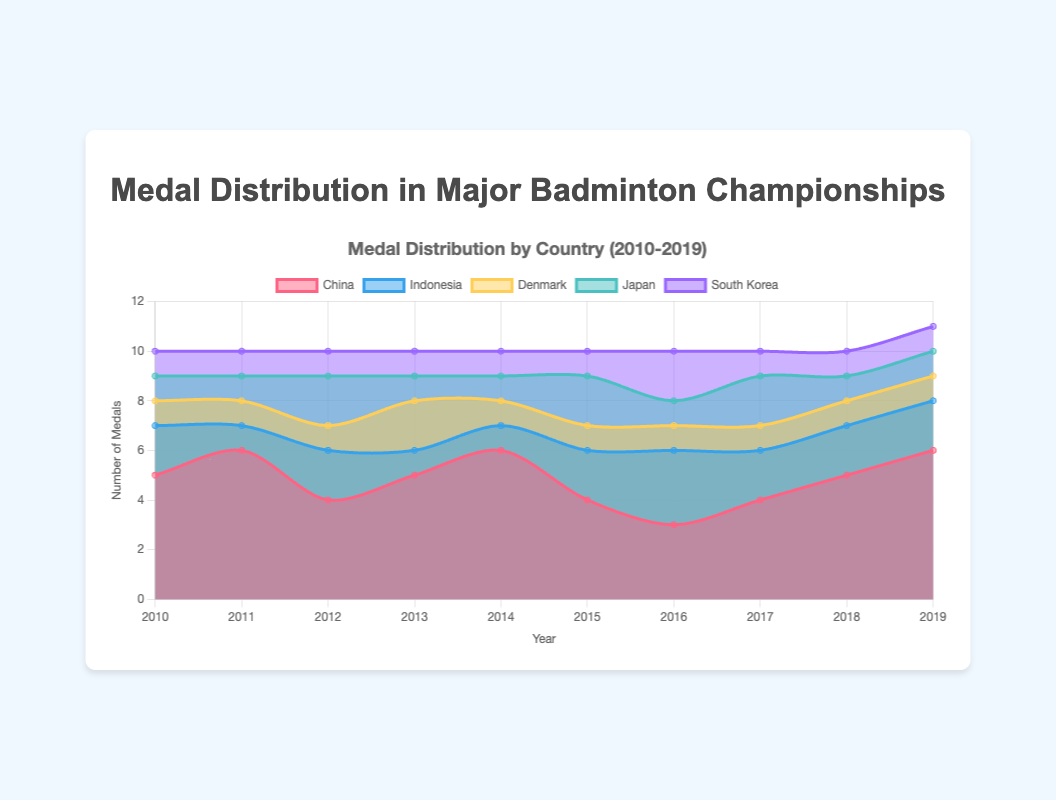What is the range of years shown in the chart? The x-axis represents the years involved in the study. The range is from the starting to the ending year displayed.
Answer: 2010-2019 How many medals did China win in 2014? Locate the data point for China in 2014 on the area chart and note the corresponding value on the y-axis.
Answer: 6 Between 2010 and 2019, in which year did Indonesia win the most medals? Check the yearly values for Indonesia and identify the year with the highest number of medals.
Answer: 2016 Which country showed the highest increase in the number of medals from 2015 to 2016? Compare the number of medals each country won in 2015 and 2016. Calculate the increase for each country and identify the highest.
Answer: Indonesia On average, how many medals did Japan win each year from 2010 to 2019? Sum the total number of medals Japan won each year from 2010 to 2019 and divide by the number of years (10).
Answer: 1.3 In which year did South Korea win the most medals, and how many medals did they win that year? Identify the peak value for South Korea on the area chart and note the corresponding year.
Answer: 2016, 2 Compare the total number of medals won by Denmark from 2010 to 2019 to that of Japan. Which country won more medals? Sum the medals Denmark and Japan won from 2010 to 2019 and compare the totals.
Answer: Japan What trend can be observed regarding China's medal wins from 2010 to 2019? Analyze the pattern of China's medal wins over the years and describe whether the number is generally increasing, decreasing, or stable.
Answer: Generally stable with a slight fluctuation In which year did the sum of medals won by all countries reach its peak? Sum the medal counts for all countries for each year and identify the year with the highest total.
Answer: 2011 Between 2016 and 2017, did China's medal count increase or decrease, and by how much? Compare the number of medals China won in 2016 and 2017 and calculate the difference.
Answer: Increase by 1 